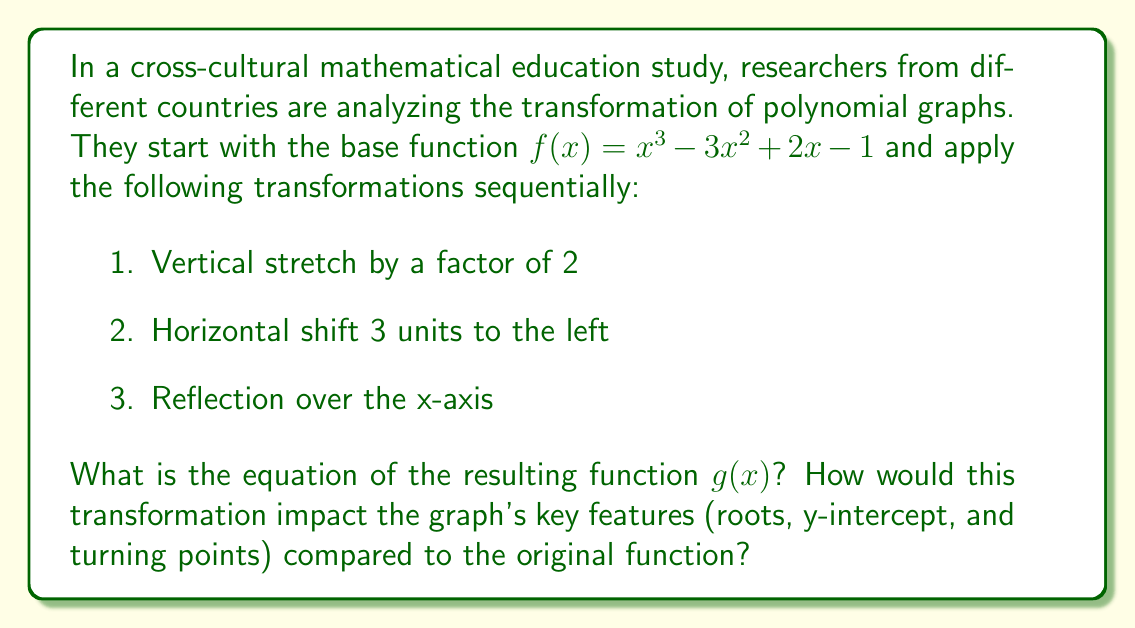Show me your answer to this math problem. Let's apply the transformations step by step:

1. Vertical stretch by a factor of 2:
   $f_1(x) = 2f(x) = 2(x^3-3x^2+2x-1) = 2x^3-6x^2+4x-2$

2. Horizontal shift 3 units to the left:
   Replace all $x$ with $(x+3)$
   $f_2(x) = 2(x+3)^3-6(x+3)^2+4(x+3)-2$
   $f_2(x) = 2(x^3+9x^2+27x+27)-6(x^2+6x+9)+4x+12-2$
   $f_2(x) = 2x^3+18x^2+54x+54-6x^2-36x-54+4x+10$
   $f_2(x) = 2x^3+12x^2+22x+10$

3. Reflection over the x-axis:
   Multiply the entire function by -1
   $g(x) = -(2x^3+12x^2+22x+10)$
   $g(x) = -2x^3-12x^2-22x-10$

Impact on key features:
1. Roots: The original roots will be shifted 3 units to the right and then reflected over the x-axis.
2. Y-intercept: The new y-intercept will be -10, which is double the negative of the original y-intercept (-1) shifted down by 8 units.
3. Turning points: The turning points will be shifted 3 units to the right, stretched vertically by a factor of 2, and then reflected over the x-axis.
Answer: $g(x) = -2x^3-12x^2-22x-10$ 